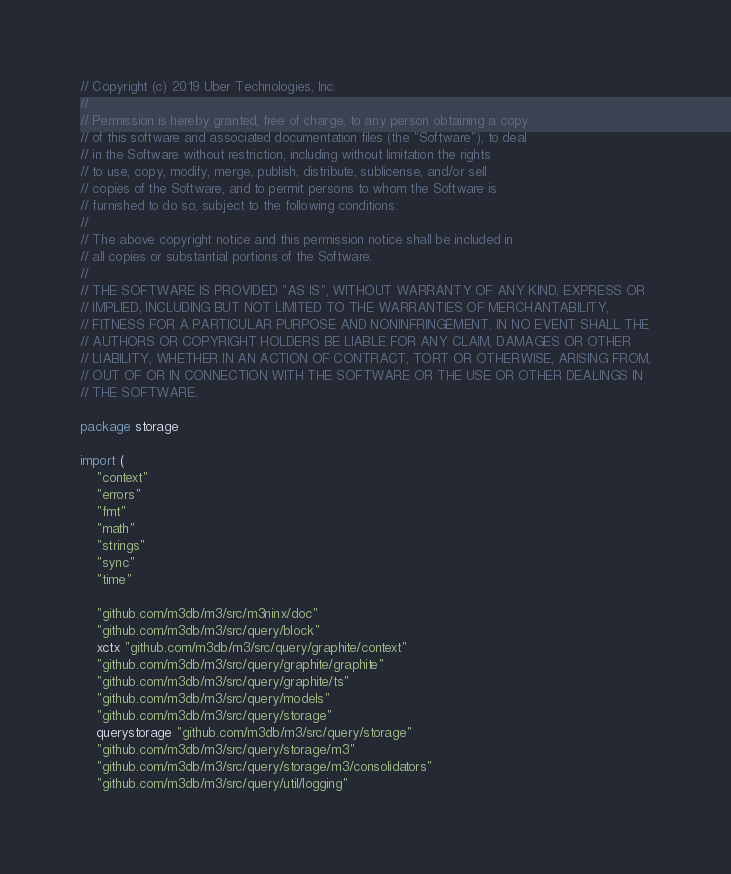<code> <loc_0><loc_0><loc_500><loc_500><_Go_>// Copyright (c) 2019 Uber Technologies, Inc.
//
// Permission is hereby granted, free of charge, to any person obtaining a copy
// of this software and associated documentation files (the "Software"), to deal
// in the Software without restriction, including without limitation the rights
// to use, copy, modify, merge, publish, distribute, sublicense, and/or sell
// copies of the Software, and to permit persons to whom the Software is
// furnished to do so, subject to the following conditions:
//
// The above copyright notice and this permission notice shall be included in
// all copies or substantial portions of the Software.
//
// THE SOFTWARE IS PROVIDED "AS IS", WITHOUT WARRANTY OF ANY KIND, EXPRESS OR
// IMPLIED, INCLUDING BUT NOT LIMITED TO THE WARRANTIES OF MERCHANTABILITY,
// FITNESS FOR A PARTICULAR PURPOSE AND NONINFRINGEMENT. IN NO EVENT SHALL THE
// AUTHORS OR COPYRIGHT HOLDERS BE LIABLE FOR ANY CLAIM, DAMAGES OR OTHER
// LIABILITY, WHETHER IN AN ACTION OF CONTRACT, TORT OR OTHERWISE, ARISING FROM,
// OUT OF OR IN CONNECTION WITH THE SOFTWARE OR THE USE OR OTHER DEALINGS IN
// THE SOFTWARE.

package storage

import (
	"context"
	"errors"
	"fmt"
	"math"
	"strings"
	"sync"
	"time"

	"github.com/m3db/m3/src/m3ninx/doc"
	"github.com/m3db/m3/src/query/block"
	xctx "github.com/m3db/m3/src/query/graphite/context"
	"github.com/m3db/m3/src/query/graphite/graphite"
	"github.com/m3db/m3/src/query/graphite/ts"
	"github.com/m3db/m3/src/query/models"
	"github.com/m3db/m3/src/query/storage"
	querystorage "github.com/m3db/m3/src/query/storage"
	"github.com/m3db/m3/src/query/storage/m3"
	"github.com/m3db/m3/src/query/storage/m3/consolidators"
	"github.com/m3db/m3/src/query/util/logging"</code> 